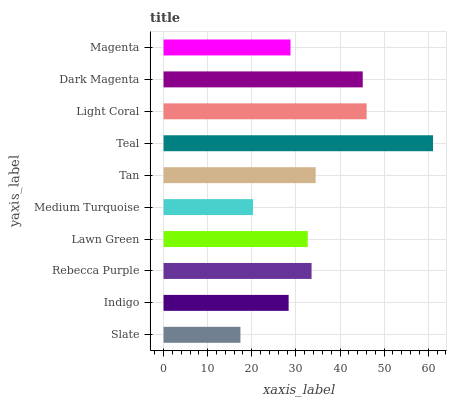Is Slate the minimum?
Answer yes or no. Yes. Is Teal the maximum?
Answer yes or no. Yes. Is Indigo the minimum?
Answer yes or no. No. Is Indigo the maximum?
Answer yes or no. No. Is Indigo greater than Slate?
Answer yes or no. Yes. Is Slate less than Indigo?
Answer yes or no. Yes. Is Slate greater than Indigo?
Answer yes or no. No. Is Indigo less than Slate?
Answer yes or no. No. Is Rebecca Purple the high median?
Answer yes or no. Yes. Is Lawn Green the low median?
Answer yes or no. Yes. Is Slate the high median?
Answer yes or no. No. Is Light Coral the low median?
Answer yes or no. No. 